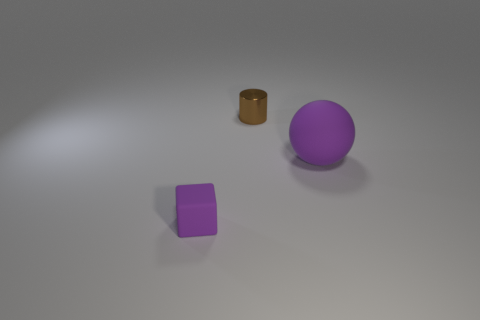Add 2 small purple rubber cylinders. How many objects exist? 5 Subtract all cubes. How many objects are left? 2 Subtract all small matte cubes. Subtract all purple blocks. How many objects are left? 1 Add 3 metallic objects. How many metallic objects are left? 4 Add 1 purple matte balls. How many purple matte balls exist? 2 Subtract 0 blue cylinders. How many objects are left? 3 